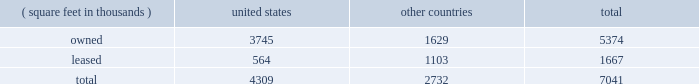Item 2 : properties information concerning applied 2019s properties at october 30 , 2016 is set forth below: .
Because of the interrelation of applied 2019s operations , properties within a country may be shared by the segments operating within that country .
The company 2019s headquarters offices are in santa clara , california .
Products in semiconductor systems are manufactured in austin , texas ; gloucester , massachusetts ; kalispell , montana ; rehovot , israel ; and singapore .
Remanufactured equipment products in the applied global services segment are produced primarily in austin , texas .
Products in the display and adjacent markets segment are manufactured in alzenau , germany ; tainan , taiwan ; and santa clara , california .
Other products are manufactured in treviso , italy .
Applied also owns and leases offices , plants and warehouse locations in many locations throughout the world , including in europe , japan , north america ( principally the united states ) , israel , china , india , korea , southeast asia and taiwan .
These facilities are principally used for manufacturing ; research , development and engineering ; and marketing , sales and customer support .
Applied also owns a total of approximately 280 acres of buildable land in montana , texas , california , massachusetts , israel and italy that could accommodate additional building space .
Applied considers the properties that it owns or leases as adequate to meet its current and future requirements .
Applied regularly assesses the size , capability and location of its global infrastructure and periodically makes adjustments based on these assessments. .
What percentage of company's properties are located in united states? 
Computations: (4309 / 7041)
Answer: 0.61199. Item 2 : properties information concerning applied 2019s properties at october 30 , 2016 is set forth below: .
Because of the interrelation of applied 2019s operations , properties within a country may be shared by the segments operating within that country .
The company 2019s headquarters offices are in santa clara , california .
Products in semiconductor systems are manufactured in austin , texas ; gloucester , massachusetts ; kalispell , montana ; rehovot , israel ; and singapore .
Remanufactured equipment products in the applied global services segment are produced primarily in austin , texas .
Products in the display and adjacent markets segment are manufactured in alzenau , germany ; tainan , taiwan ; and santa clara , california .
Other products are manufactured in treviso , italy .
Applied also owns and leases offices , plants and warehouse locations in many locations throughout the world , including in europe , japan , north america ( principally the united states ) , israel , china , india , korea , southeast asia and taiwan .
These facilities are principally used for manufacturing ; research , development and engineering ; and marketing , sales and customer support .
Applied also owns a total of approximately 280 acres of buildable land in montana , texas , california , massachusetts , israel and italy that could accommodate additional building space .
Applied considers the properties that it owns or leases as adequate to meet its current and future requirements .
Applied regularly assesses the size , capability and location of its global infrastructure and periodically makes adjustments based on these assessments. .
What percentage of company's properties are leased? 
Computations: (1667 / 7041)
Answer: 0.23676. 